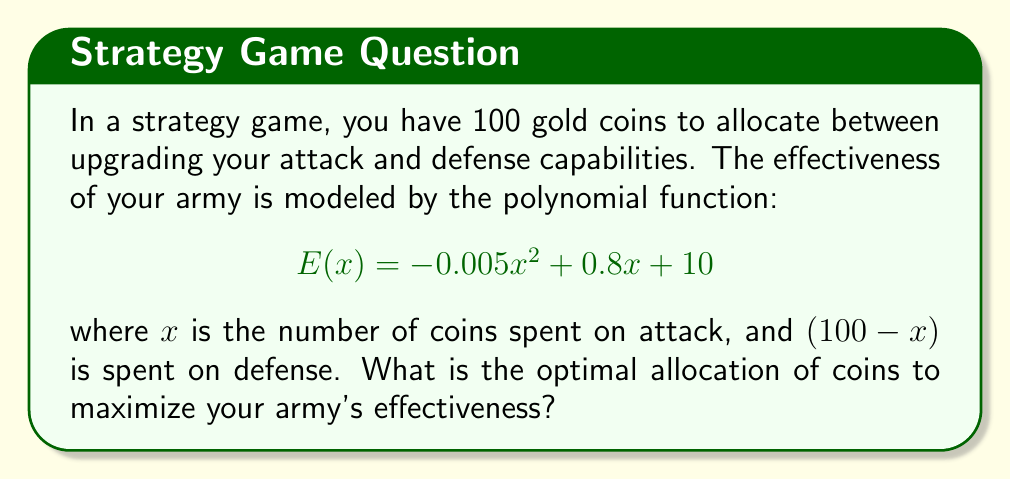What is the answer to this math problem? To find the optimal allocation, we need to maximize the function $E(x)$. This can be done by finding the vertex of the parabola:

1) The general form of a quadratic function is $f(x) = ax^2 + bx + c$
   Here, $a = -0.005$, $b = 0.8$, and $c = 10$

2) The x-coordinate of the vertex is given by $x = -\frac{b}{2a}$

3) Substituting our values:
   $$x = -\frac{0.8}{2(-0.005)} = -\frac{0.8}{-0.01} = 80$$

4) To verify this is a maximum (not minimum), note that $a < 0$, confirming a downward-facing parabola

5) Since $x$ represents coins spent on attack, and we have 100 coins total:
   Coins for attack: 80
   Coins for defense: 100 - 80 = 20

6) We can confirm by testing values on either side of $x = 80$:
   $E(79) = -0.005(79)^2 + 0.8(79) + 10 = 41.795$
   $E(80) = -0.005(80)^2 + 0.8(80) + 10 = 42$
   $E(81) = -0.005(81)^2 + 0.8(81) + 10 = 41.995$

Therefore, the optimal allocation is 80 coins for attack and 20 coins for defense.
Answer: 80 coins for attack, 20 for defense 